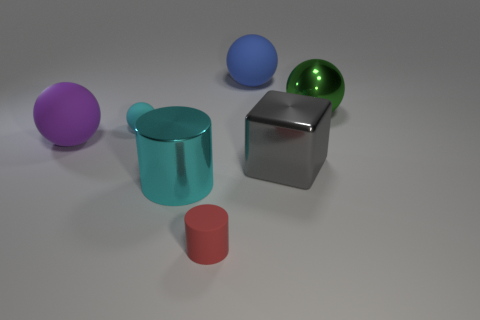How many objects are small purple metallic balls or large matte balls?
Ensure brevity in your answer.  2. There is a rubber object in front of the cube; is it the same size as the cyan rubber thing behind the tiny red thing?
Provide a short and direct response. Yes. What number of other things are the same material as the small red object?
Offer a very short reply. 3. Are there more shiny things that are to the left of the large blue matte ball than purple matte things to the left of the big purple matte thing?
Provide a succinct answer. Yes. There is a small object that is in front of the block; what is it made of?
Offer a terse response. Rubber. Do the purple object and the green object have the same shape?
Provide a short and direct response. Yes. Is there any other thing that is the same color as the big shiny sphere?
Your answer should be compact. No. What color is the other big matte object that is the same shape as the purple thing?
Make the answer very short. Blue. Is the number of large gray cubes to the right of the small cyan sphere greater than the number of yellow metallic things?
Your answer should be compact. Yes. What is the color of the large metallic thing on the left side of the tiny red object?
Provide a succinct answer. Cyan. 